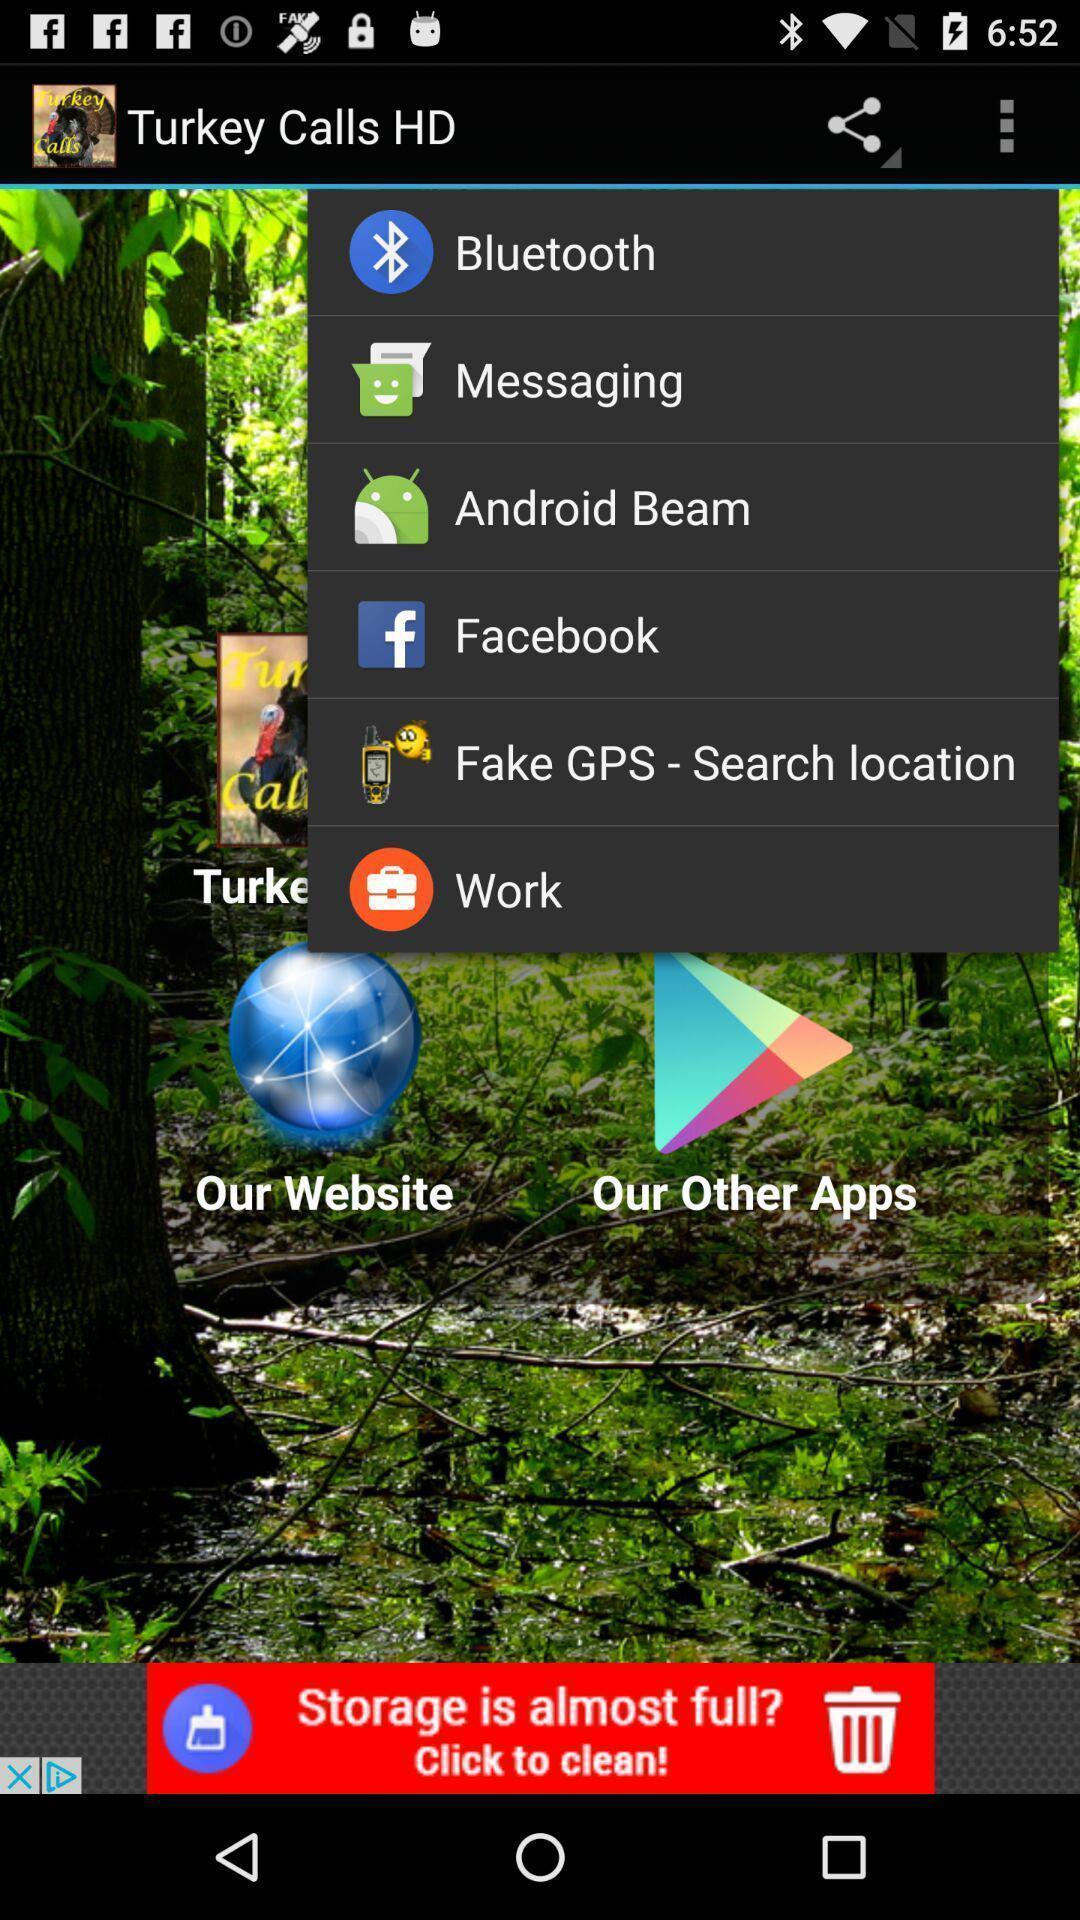What can you discern from this picture? Screen shows multiple options. 